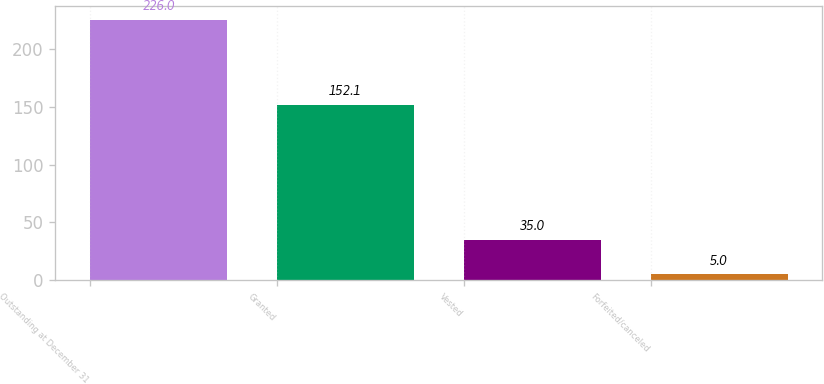<chart> <loc_0><loc_0><loc_500><loc_500><bar_chart><fcel>Outstanding at December 31<fcel>Granted<fcel>Vested<fcel>Forfeited/canceled<nl><fcel>226<fcel>152.1<fcel>35<fcel>5<nl></chart> 